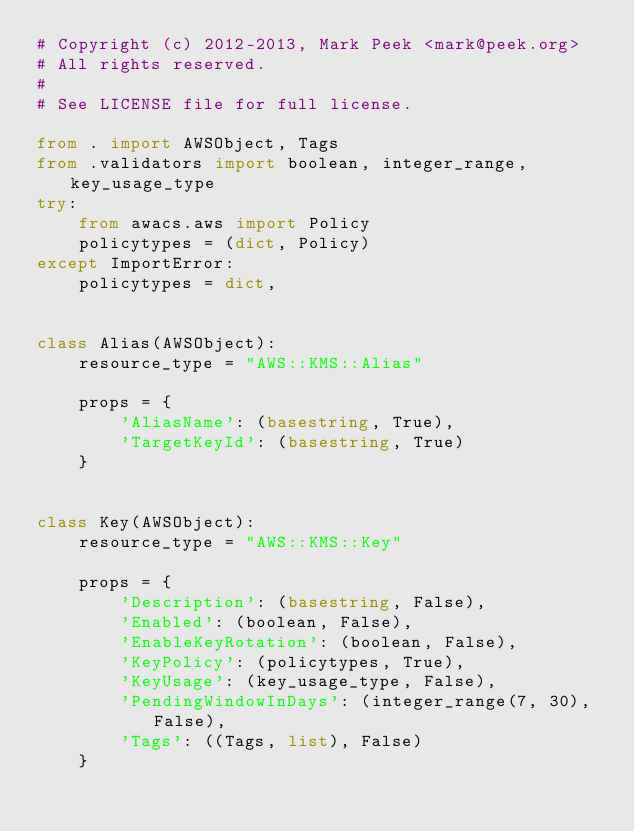Convert code to text. <code><loc_0><loc_0><loc_500><loc_500><_Python_># Copyright (c) 2012-2013, Mark Peek <mark@peek.org>
# All rights reserved.
#
# See LICENSE file for full license.

from . import AWSObject, Tags
from .validators import boolean, integer_range, key_usage_type
try:
    from awacs.aws import Policy
    policytypes = (dict, Policy)
except ImportError:
    policytypes = dict,


class Alias(AWSObject):
    resource_type = "AWS::KMS::Alias"

    props = {
        'AliasName': (basestring, True),
        'TargetKeyId': (basestring, True)
    }


class Key(AWSObject):
    resource_type = "AWS::KMS::Key"

    props = {
        'Description': (basestring, False),
        'Enabled': (boolean, False),
        'EnableKeyRotation': (boolean, False),
        'KeyPolicy': (policytypes, True),
        'KeyUsage': (key_usage_type, False),
        'PendingWindowInDays': (integer_range(7, 30), False),
        'Tags': ((Tags, list), False)
    }
</code> 